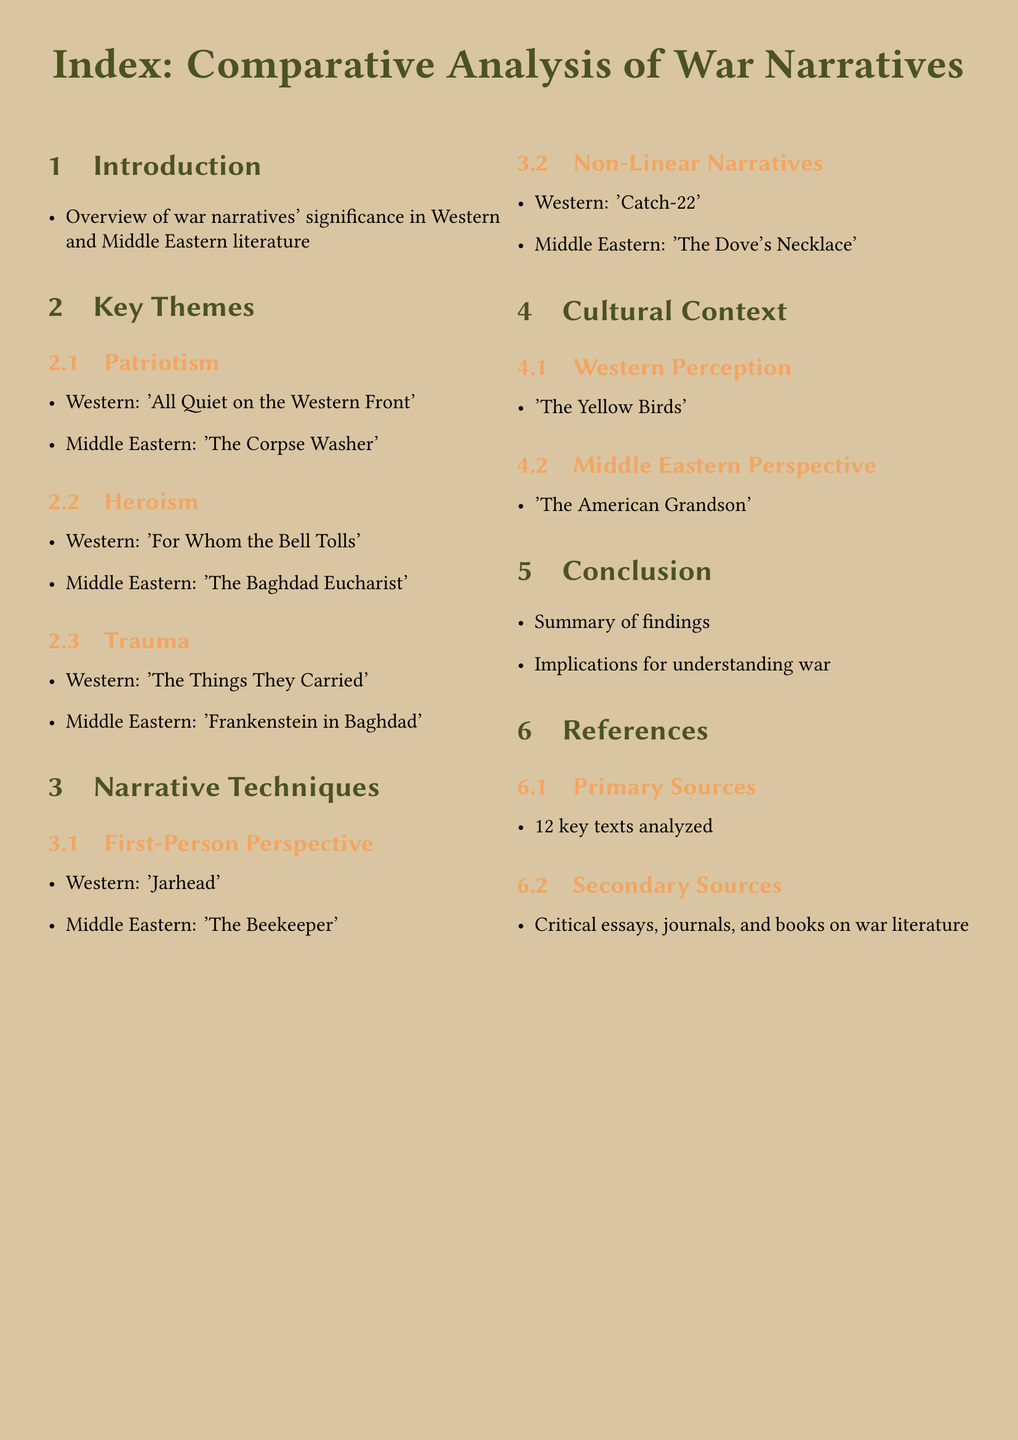What is the title of the document? The title is provided at the beginning of the index document.
Answer: Index: Comparative Analysis of War Narratives What is the primary theme discussed in 'All Quiet on the Western Front'? This title is listed under the theme of Patriotism in Western literature.
Answer: Patriotism Which Middle Eastern text is associated with Trauma? The document lists this text under the theme of Trauma in Middle Eastern literature.
Answer: Frankenstein in Baghdad How many key themes are identified in the index? The themes are categorized under sections in the document.
Answer: Three What narrative technique is exemplified by 'Catch-22'? This title is mentioned under a specific subsection regarding narrative techniques in the document.
Answer: Non-Linear Narratives Which text represents Western perception in this analysis? This information is found in the Cultural Context section of the index.
Answer: The Yellow Birds How many primary sources are analyzed in the document? This number is stated in the References section of the index.
Answer: 12 What is the purpose of the conclusion section? The conclusion summarizes the findings and their implications.
Answer: Summary of findings Which narrative technique is illustrated by 'The Beekeeper'? The document labels this technique in relation to a specific text.
Answer: First-Person Perspective 